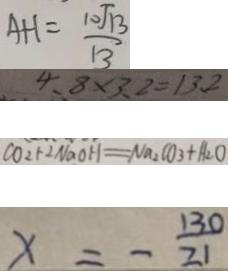Convert formula to latex. <formula><loc_0><loc_0><loc_500><loc_500>A H = \frac { 1 0 \sqrt { 1 3 } } { 1 3 } 
 4 . 8 \times 3 . 2 = 1 3 . 2 
 C O _ { 2 } + 2 N a O H = N a _ { 2 } C O _ { 3 } + H _ { 2 } O 
 \times = - \frac { 1 3 0 } { 2 1 }</formula> 